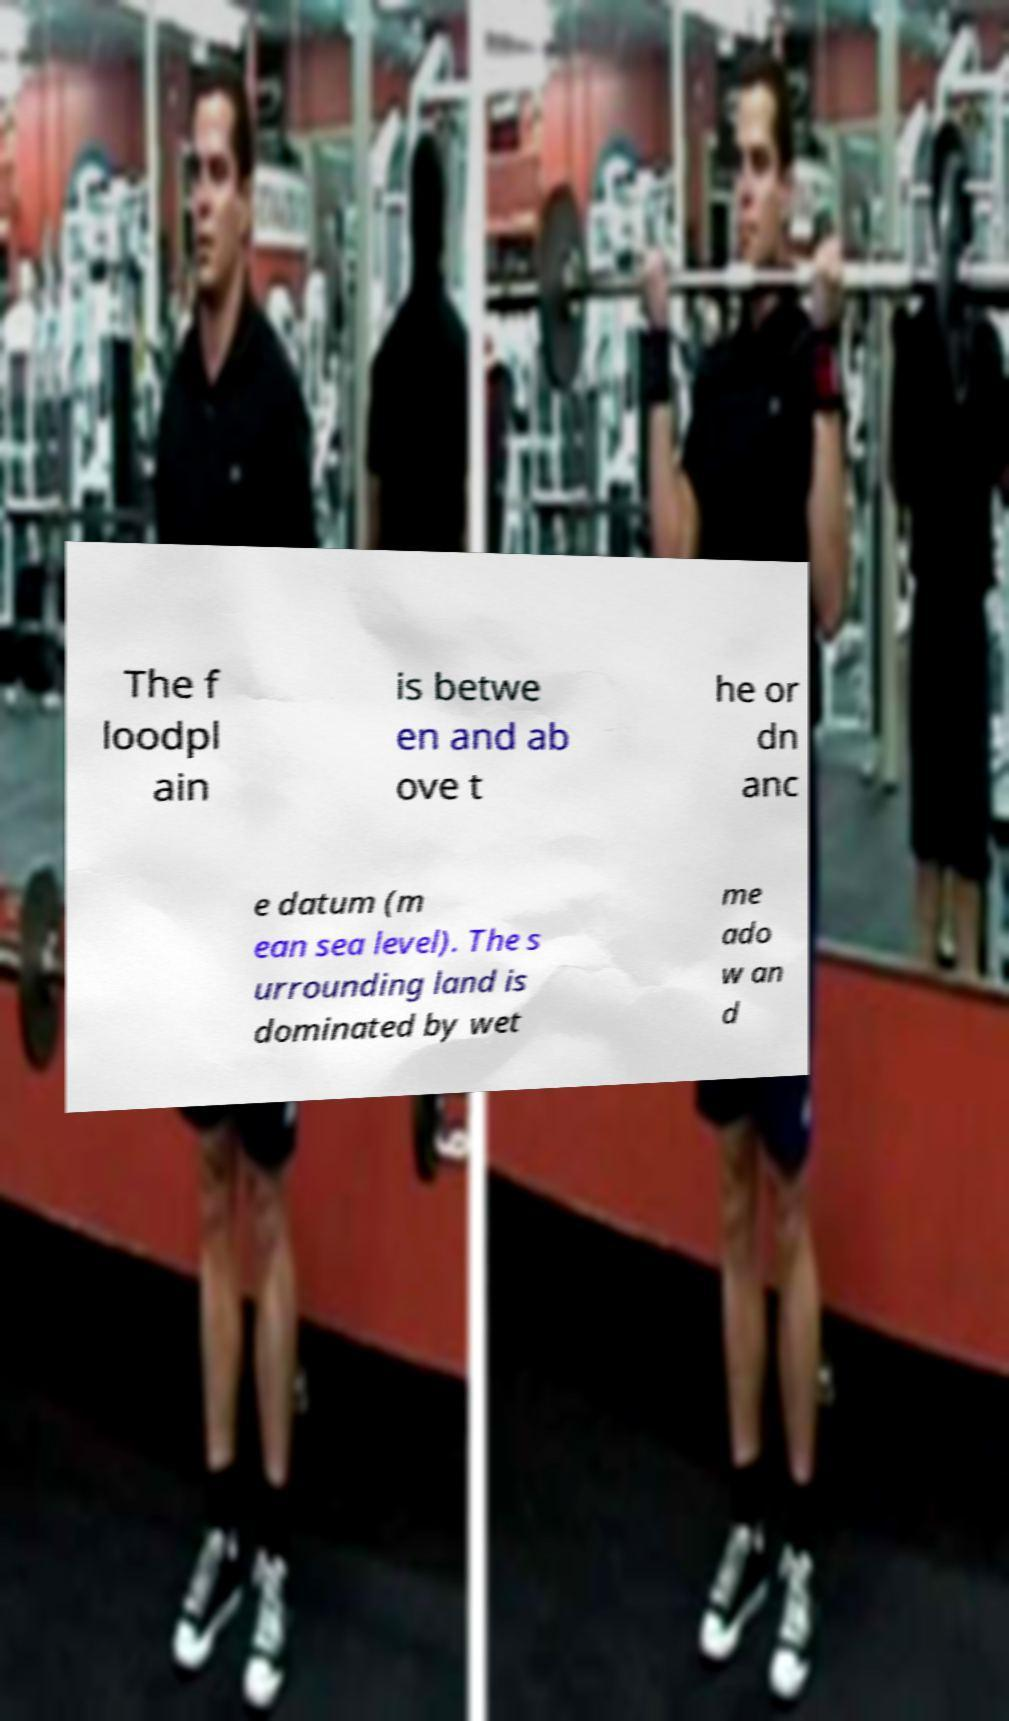What messages or text are displayed in this image? I need them in a readable, typed format. The f loodpl ain is betwe en and ab ove t he or dn anc e datum (m ean sea level). The s urrounding land is dominated by wet me ado w an d 